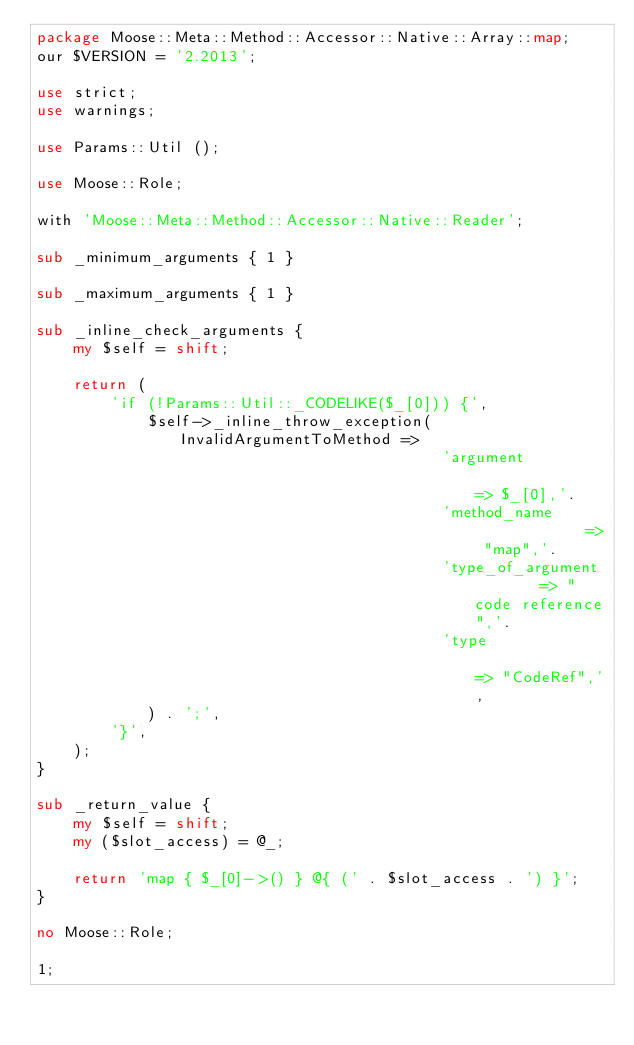Convert code to text. <code><loc_0><loc_0><loc_500><loc_500><_Perl_>package Moose::Meta::Method::Accessor::Native::Array::map;
our $VERSION = '2.2013';

use strict;
use warnings;

use Params::Util ();

use Moose::Role;

with 'Moose::Meta::Method::Accessor::Native::Reader';

sub _minimum_arguments { 1 }

sub _maximum_arguments { 1 }

sub _inline_check_arguments {
    my $self = shift;

    return (
        'if (!Params::Util::_CODELIKE($_[0])) {',
            $self->_inline_throw_exception( InvalidArgumentToMethod =>
                                            'argument                => $_[0],'.
                                            'method_name             => "map",'.
                                            'type_of_argument        => "code reference",'.
                                            'type                    => "CodeRef",',
            ) . ';',
        '}',
    );
}

sub _return_value {
    my $self = shift;
    my ($slot_access) = @_;

    return 'map { $_[0]->() } @{ (' . $slot_access . ') }';
}

no Moose::Role;

1;
</code> 